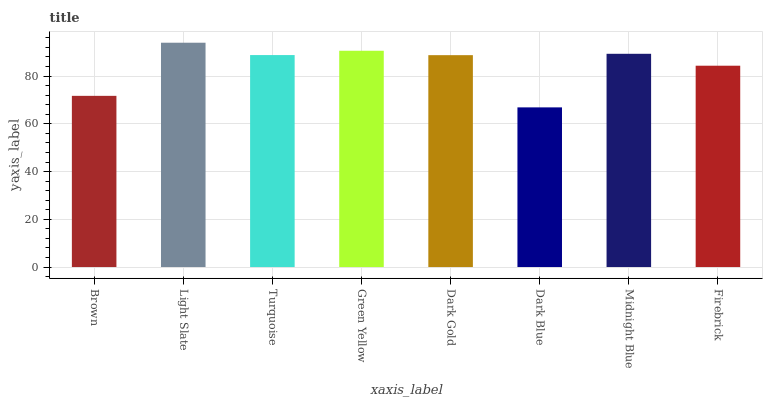Is Dark Blue the minimum?
Answer yes or no. Yes. Is Light Slate the maximum?
Answer yes or no. Yes. Is Turquoise the minimum?
Answer yes or no. No. Is Turquoise the maximum?
Answer yes or no. No. Is Light Slate greater than Turquoise?
Answer yes or no. Yes. Is Turquoise less than Light Slate?
Answer yes or no. Yes. Is Turquoise greater than Light Slate?
Answer yes or no. No. Is Light Slate less than Turquoise?
Answer yes or no. No. Is Turquoise the high median?
Answer yes or no. Yes. Is Dark Gold the low median?
Answer yes or no. Yes. Is Dark Blue the high median?
Answer yes or no. No. Is Brown the low median?
Answer yes or no. No. 